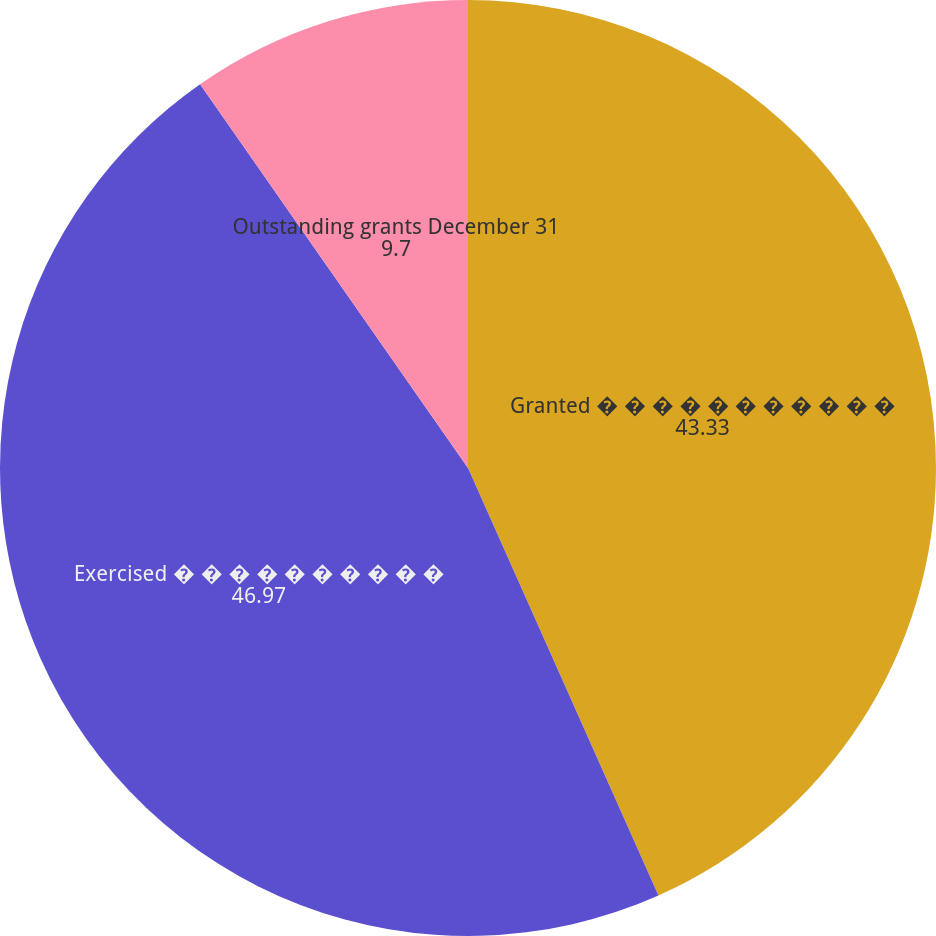<chart> <loc_0><loc_0><loc_500><loc_500><pie_chart><fcel>Granted � � � � � � � � � � �<fcel>Exercised � � � � � � � � � �<fcel>Outstanding grants December 31<nl><fcel>43.33%<fcel>46.97%<fcel>9.7%<nl></chart> 